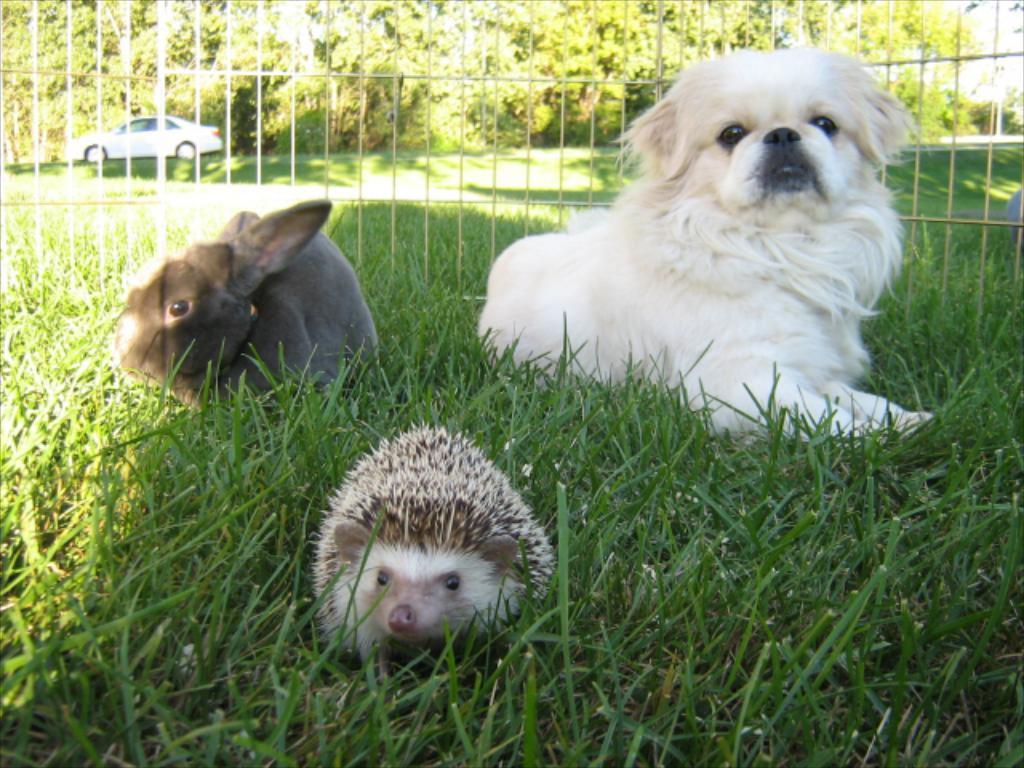Can you describe this image briefly? In this image we can see animals on the grass. Near to them there is a mesh fencing. In the back there is a car. Also there are trees. 